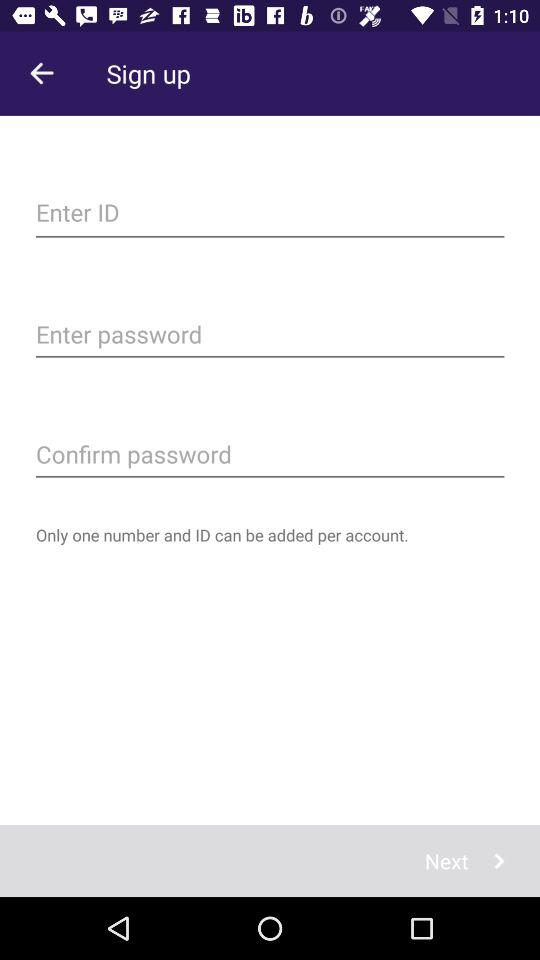What is the name of the application?
When the provided information is insufficient, respond with <no answer>. <no answer> 